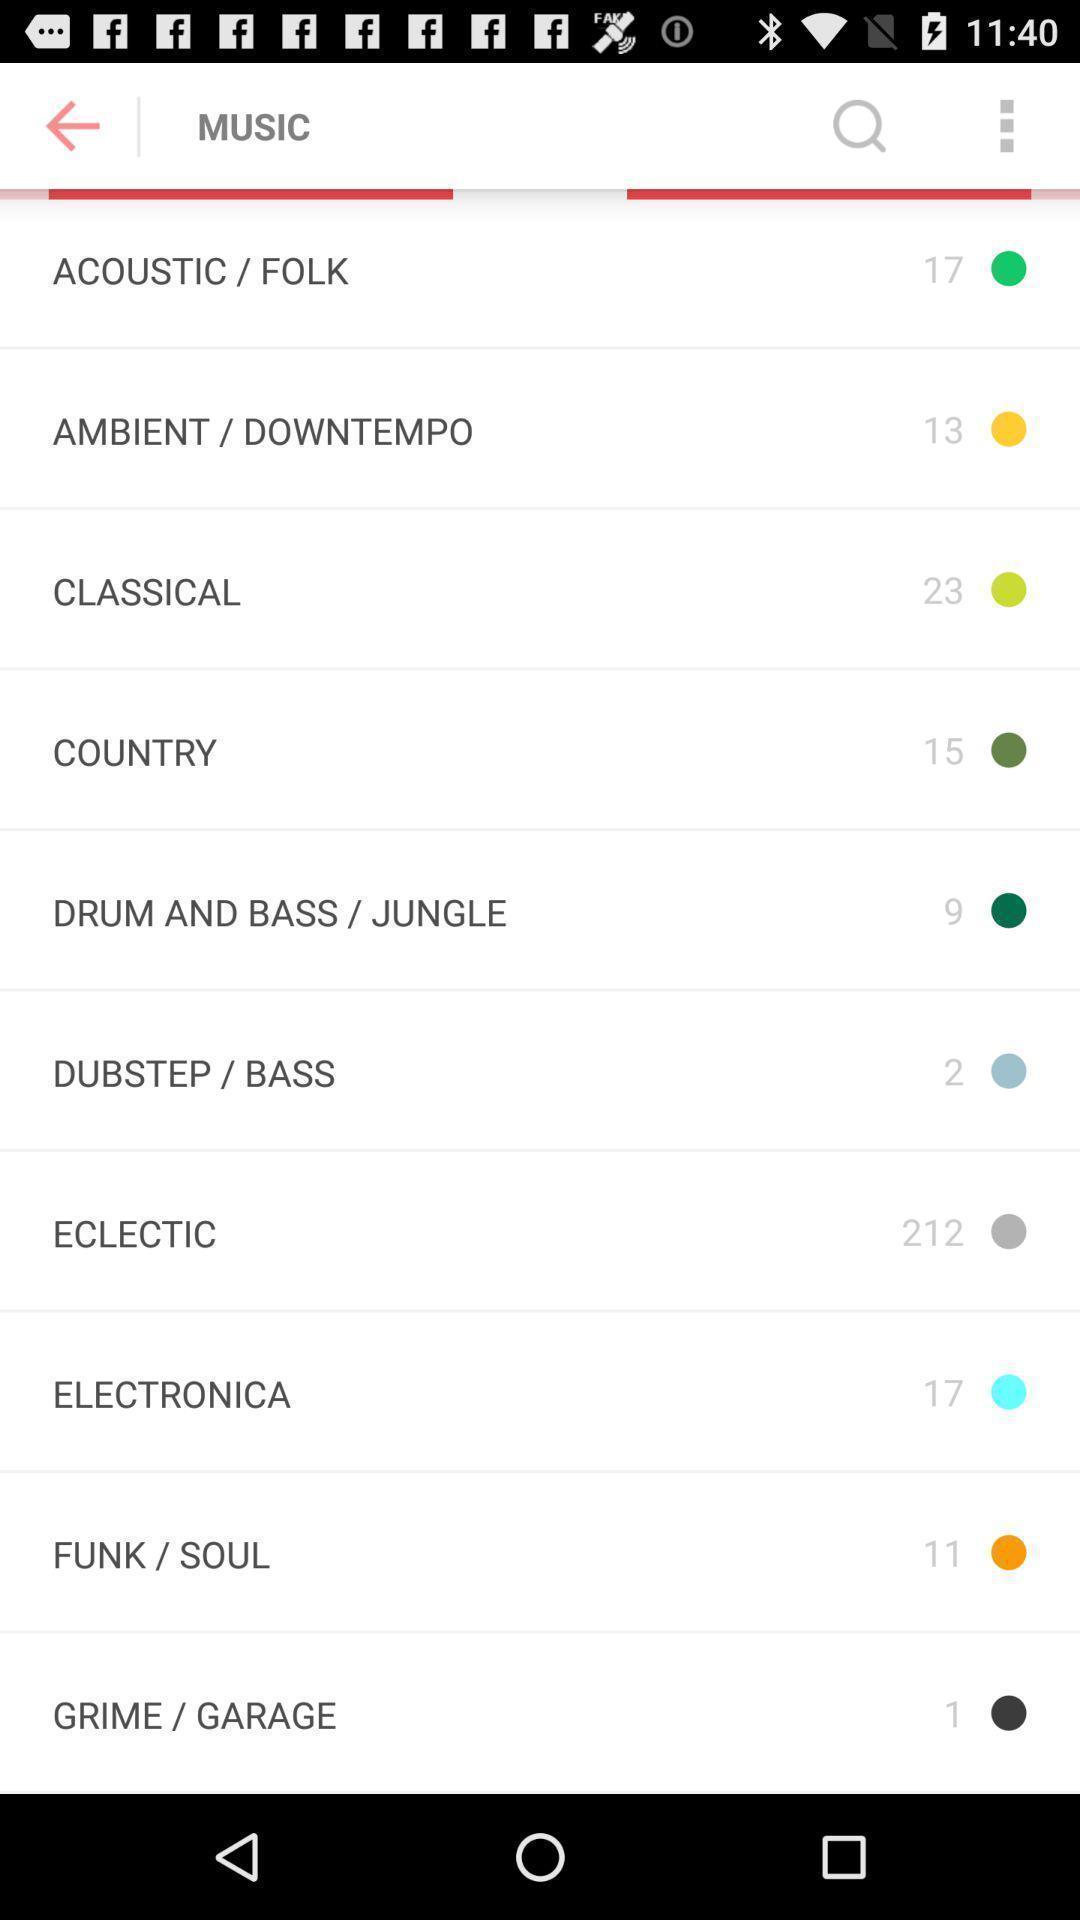Describe this image in words. Various types of music sounds are displaying. 